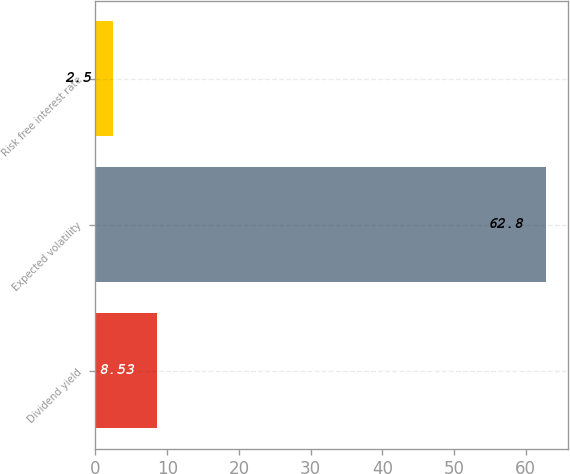Convert chart to OTSL. <chart><loc_0><loc_0><loc_500><loc_500><bar_chart><fcel>Dividend yield<fcel>Expected volatility<fcel>Risk free interest rate<nl><fcel>8.53<fcel>62.8<fcel>2.5<nl></chart> 